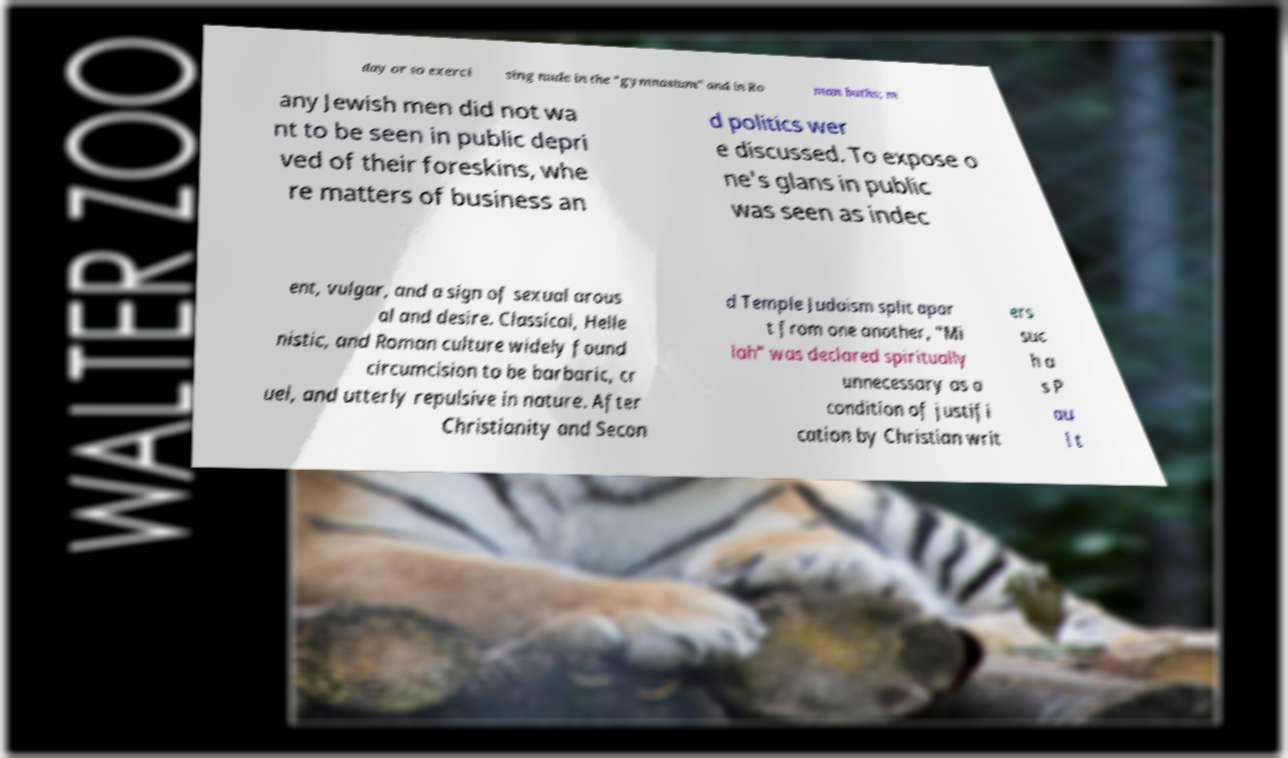There's text embedded in this image that I need extracted. Can you transcribe it verbatim? day or so exerci sing nude in the "gymnasium" and in Ro man baths; m any Jewish men did not wa nt to be seen in public depri ved of their foreskins, whe re matters of business an d politics wer e discussed. To expose o ne's glans in public was seen as indec ent, vulgar, and a sign of sexual arous al and desire. Classical, Helle nistic, and Roman culture widely found circumcision to be barbaric, cr uel, and utterly repulsive in nature. After Christianity and Secon d Temple Judaism split apar t from one another, "Mi lah" was declared spiritually unnecessary as a condition of justifi cation by Christian writ ers suc h a s P au l t 